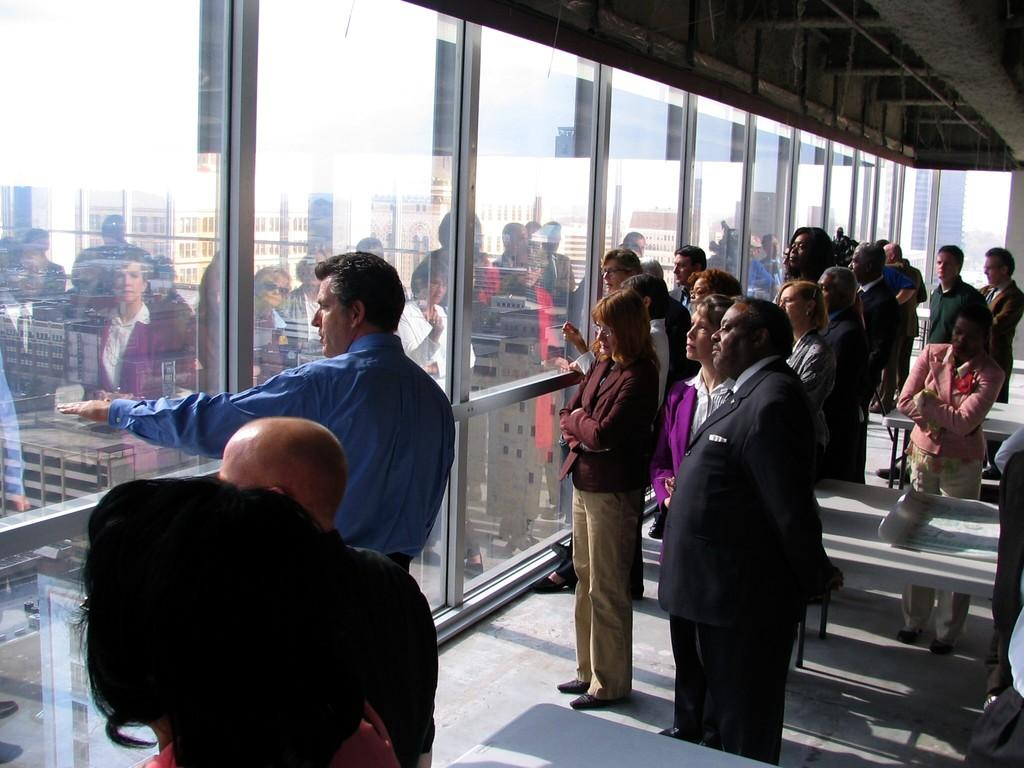How many people can be seen in the image? There are many people standing on the floor in the image. What type of barrier separates the people from the buildings in the image? There is a glass wall in the image. What can be seen through the glass wall? Buildings are visible behind the glass wall. Where are the buildings located in relation to the glass wall? The buildings are on the land. What type of education is being offered in the image? There is no indication of education being offered in the image. 